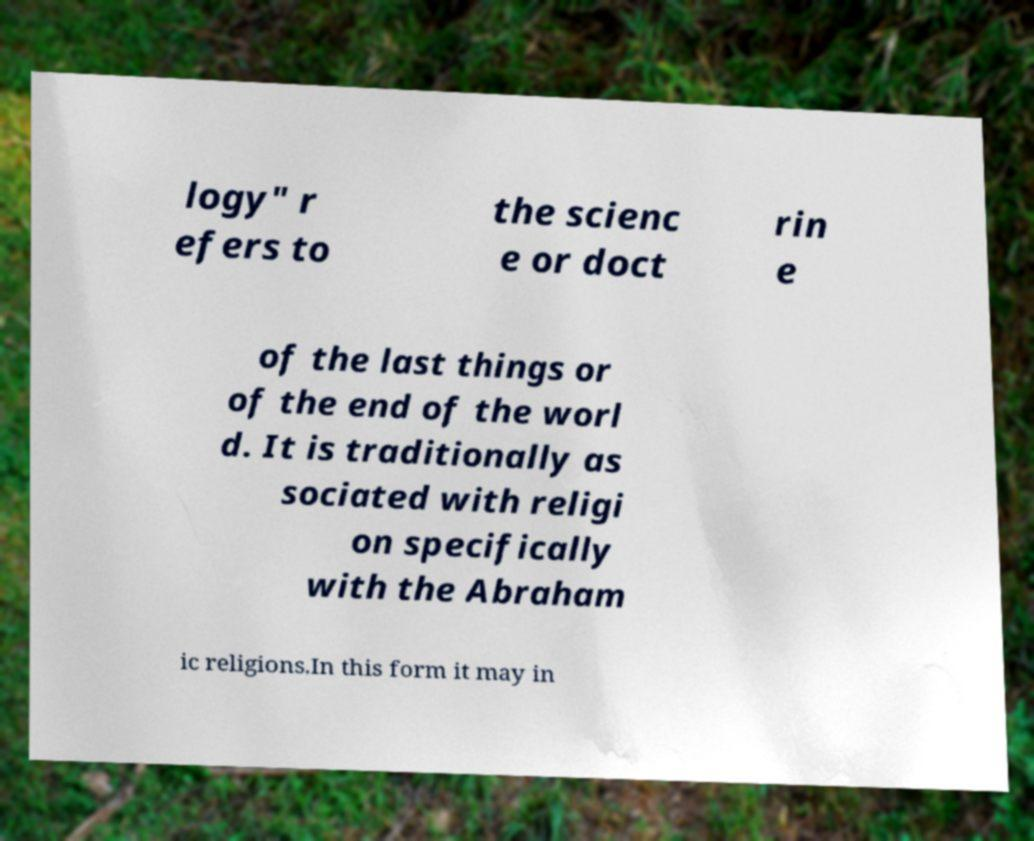Please identify and transcribe the text found in this image. logy" r efers to the scienc e or doct rin e of the last things or of the end of the worl d. It is traditionally as sociated with religi on specifically with the Abraham ic religions.In this form it may in 